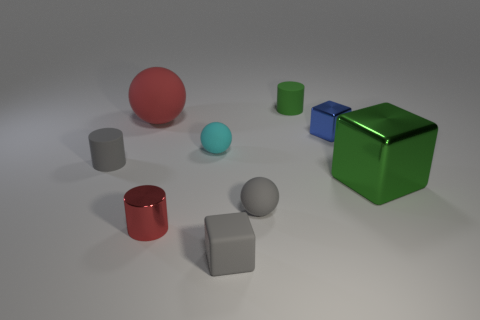There is a small cylinder that is the same color as the tiny matte block; what material is it?
Your answer should be compact. Rubber. How many things are tiny matte cylinders or tiny red matte cylinders?
Make the answer very short. 2. There is another object that is the same size as the green shiny object; what material is it?
Offer a very short reply. Rubber. How big is the red thing that is behind the red metal object?
Make the answer very short. Large. What is the material of the small blue cube?
Give a very brief answer. Metal. What number of objects are spheres left of the green block or things that are on the right side of the red metallic cylinder?
Provide a succinct answer. 7. How many other objects are there of the same color as the matte block?
Your answer should be compact. 2. There is a big metallic object; does it have the same shape as the small shiny object to the right of the tiny cyan thing?
Offer a very short reply. Yes. Are there fewer small red metal objects that are behind the small cyan sphere than rubber objects that are right of the red ball?
Make the answer very short. Yes. There is a gray object that is the same shape as the big green object; what is its material?
Your response must be concise. Rubber. 